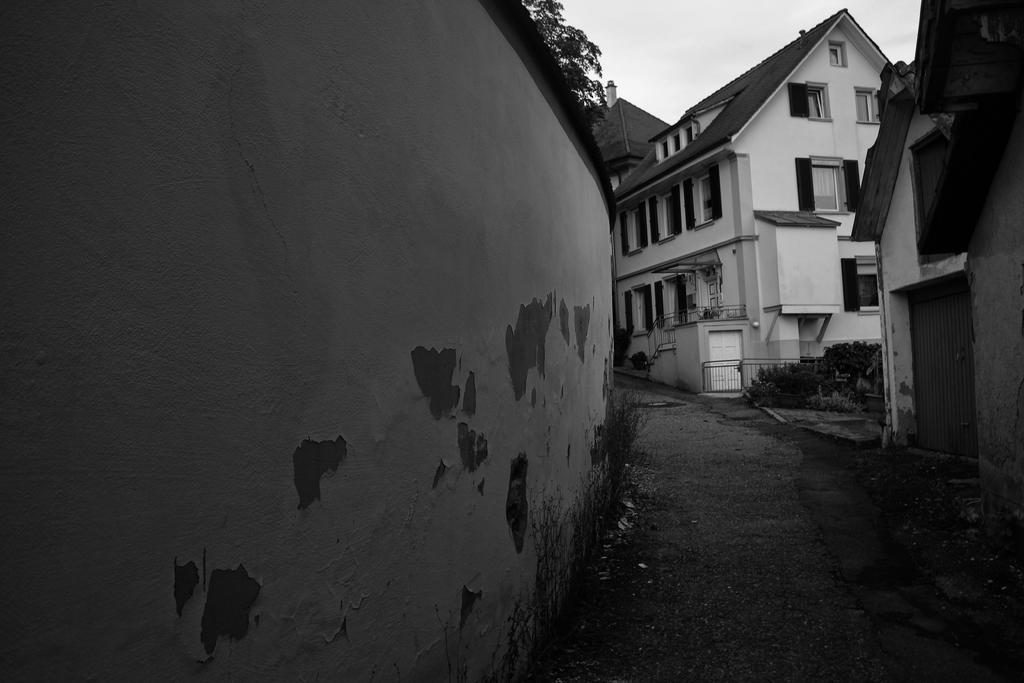What type of structure can be seen in the image? There is a wall in the image. What else is present in the image besides the wall? There are plants and houses in the image. What can be seen in the background of the image? The sky is visible in the background of the image. What type of flowers are growing on the wall in the image? There are no flowers growing on the wall in the image; it only shows a wall, plants, houses, and the sky. Can you tell me who gave their approval for the wall in the image? There is no information about who gave their approval for the wall in the image, as it is not relevant to the facts provided. 